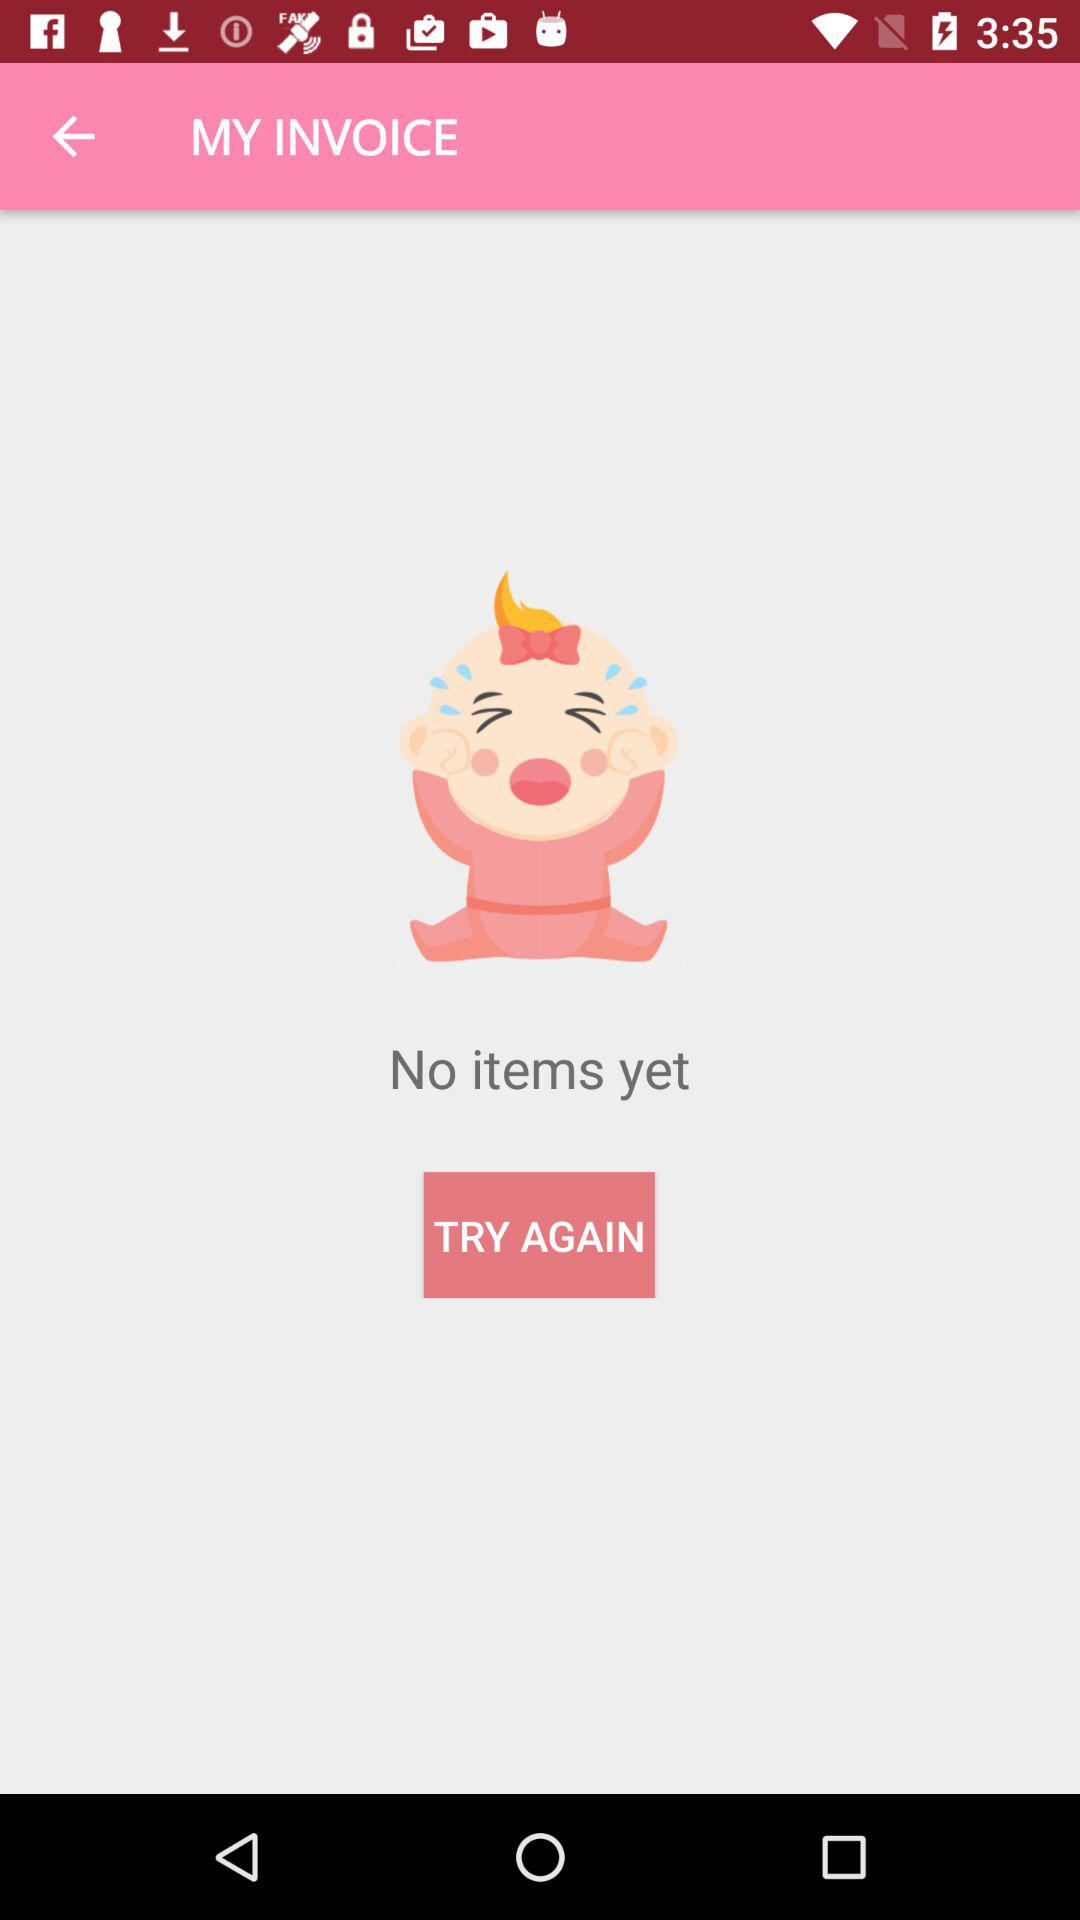What is the version of this application?
When the provided information is insufficient, respond with <no answer>. <no answer> 